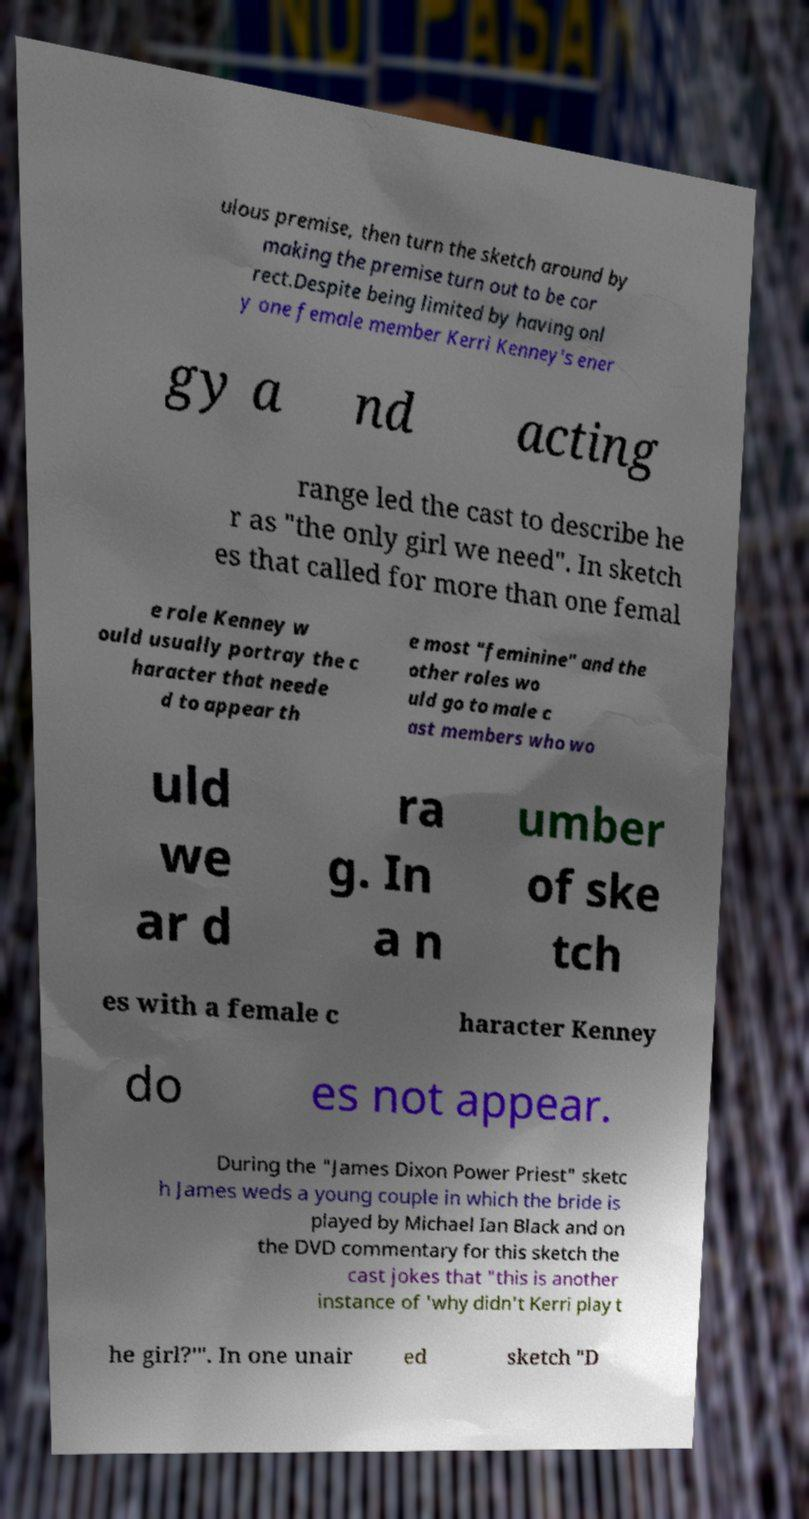Could you assist in decoding the text presented in this image and type it out clearly? ulous premise, then turn the sketch around by making the premise turn out to be cor rect.Despite being limited by having onl y one female member Kerri Kenney's ener gy a nd acting range led the cast to describe he r as "the only girl we need". In sketch es that called for more than one femal e role Kenney w ould usually portray the c haracter that neede d to appear th e most "feminine" and the other roles wo uld go to male c ast members who wo uld we ar d ra g. In a n umber of ske tch es with a female c haracter Kenney do es not appear. During the "James Dixon Power Priest" sketc h James weds a young couple in which the bride is played by Michael Ian Black and on the DVD commentary for this sketch the cast jokes that "this is another instance of 'why didn't Kerri play t he girl?'". In one unair ed sketch "D 